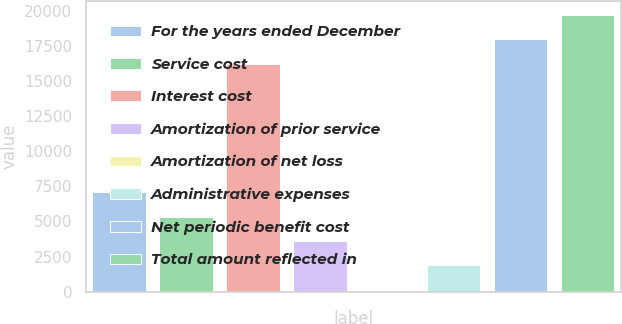Convert chart. <chart><loc_0><loc_0><loc_500><loc_500><bar_chart><fcel>For the years ended December<fcel>Service cost<fcel>Interest cost<fcel>Amortization of prior service<fcel>Amortization of net loss<fcel>Administrative expenses<fcel>Net periodic benefit cost<fcel>Total amount reflected in<nl><fcel>7075.8<fcel>5340.6<fcel>16254<fcel>3605.4<fcel>135<fcel>1870.2<fcel>17989.2<fcel>19724.4<nl></chart> 